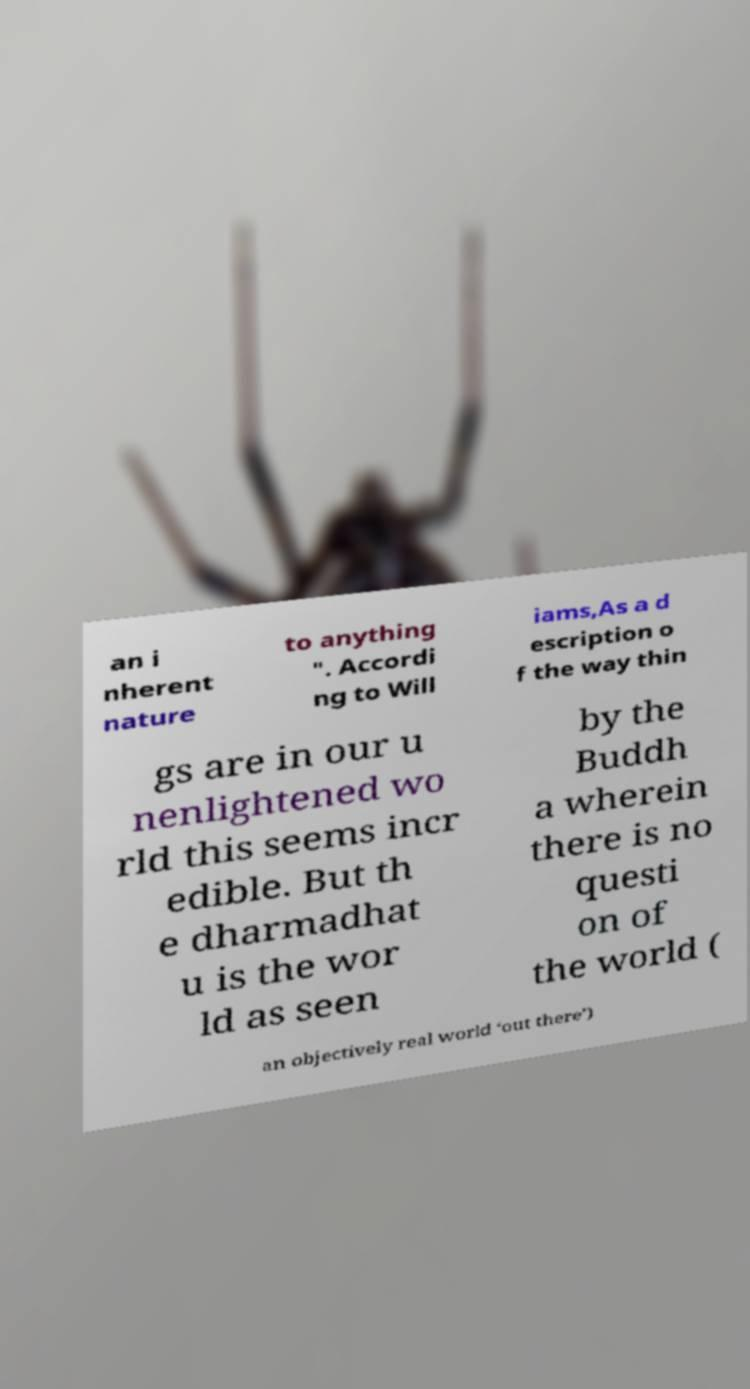There's text embedded in this image that I need extracted. Can you transcribe it verbatim? an i nherent nature to anything ". Accordi ng to Will iams,As a d escription o f the way thin gs are in our u nenlightened wo rld this seems incr edible. But th e dharmadhat u is the wor ld as seen by the Buddh a wherein there is no questi on of the world ( an objectively real world ‘out there’) 